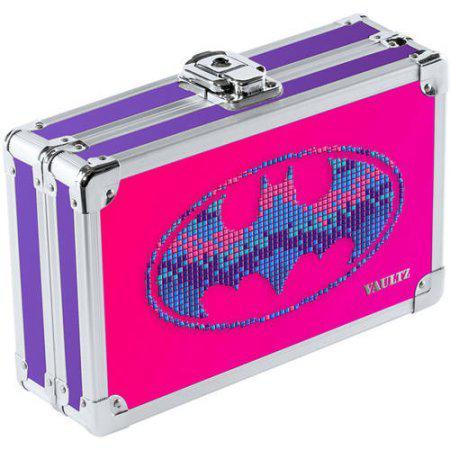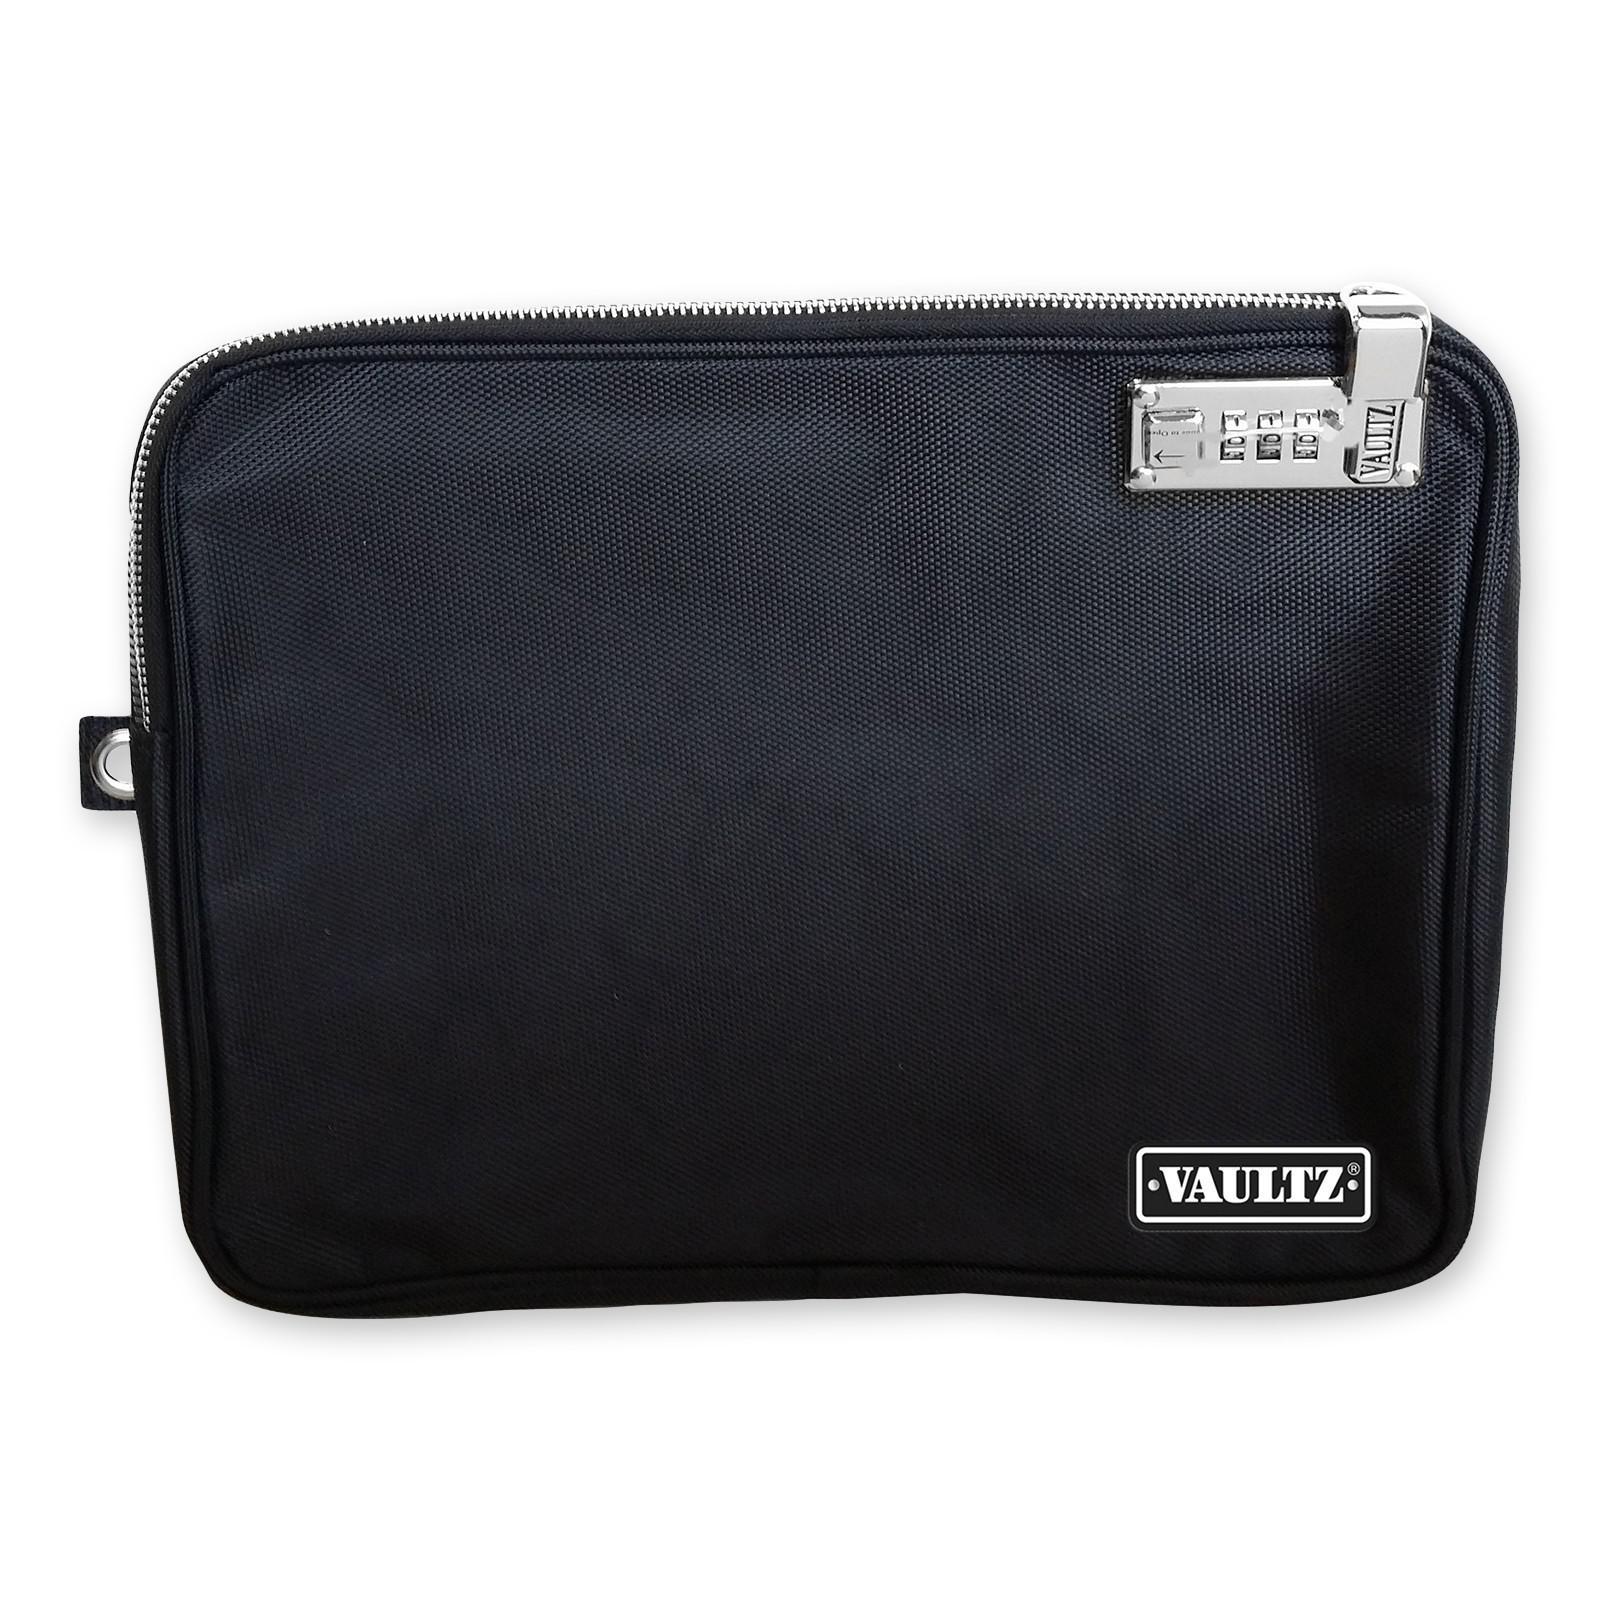The first image is the image on the left, the second image is the image on the right. For the images shown, is this caption "In one of the images there is a suitcase that is sitting at a 45 degree angle." true? Answer yes or no. Yes. The first image is the image on the left, the second image is the image on the right. Analyze the images presented: Is the assertion "There is a batman logo." valid? Answer yes or no. Yes. 